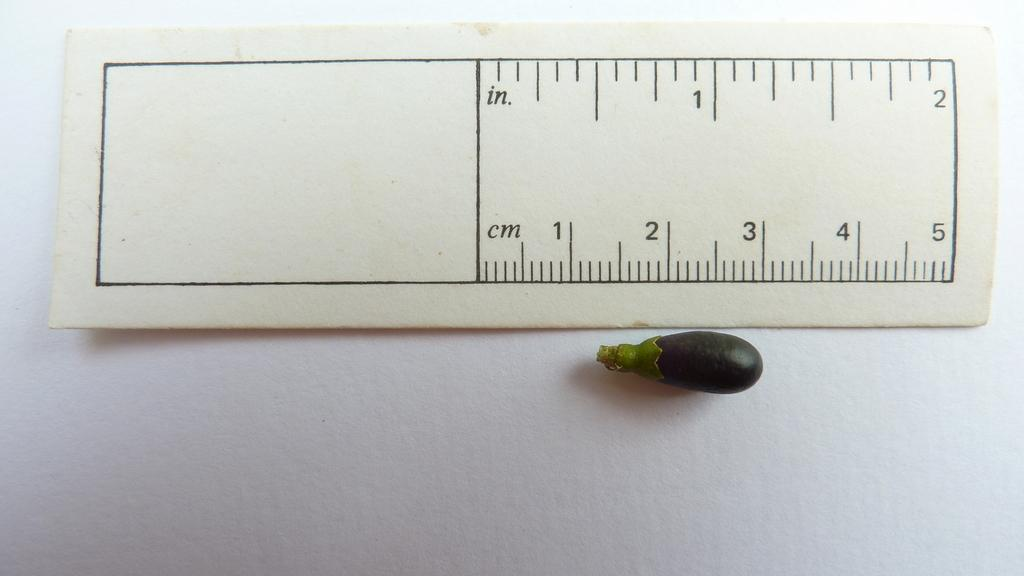<image>
Create a compact narrative representing the image presented. The ruler here can be used for both inches and centimeters 